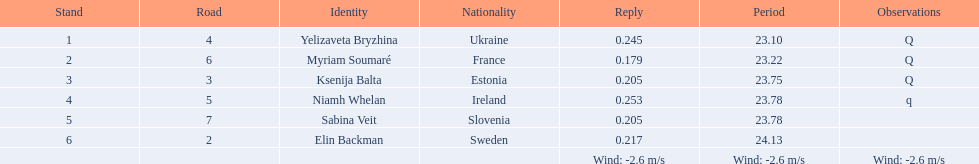Are any of the lanes in consecutive order? No. 